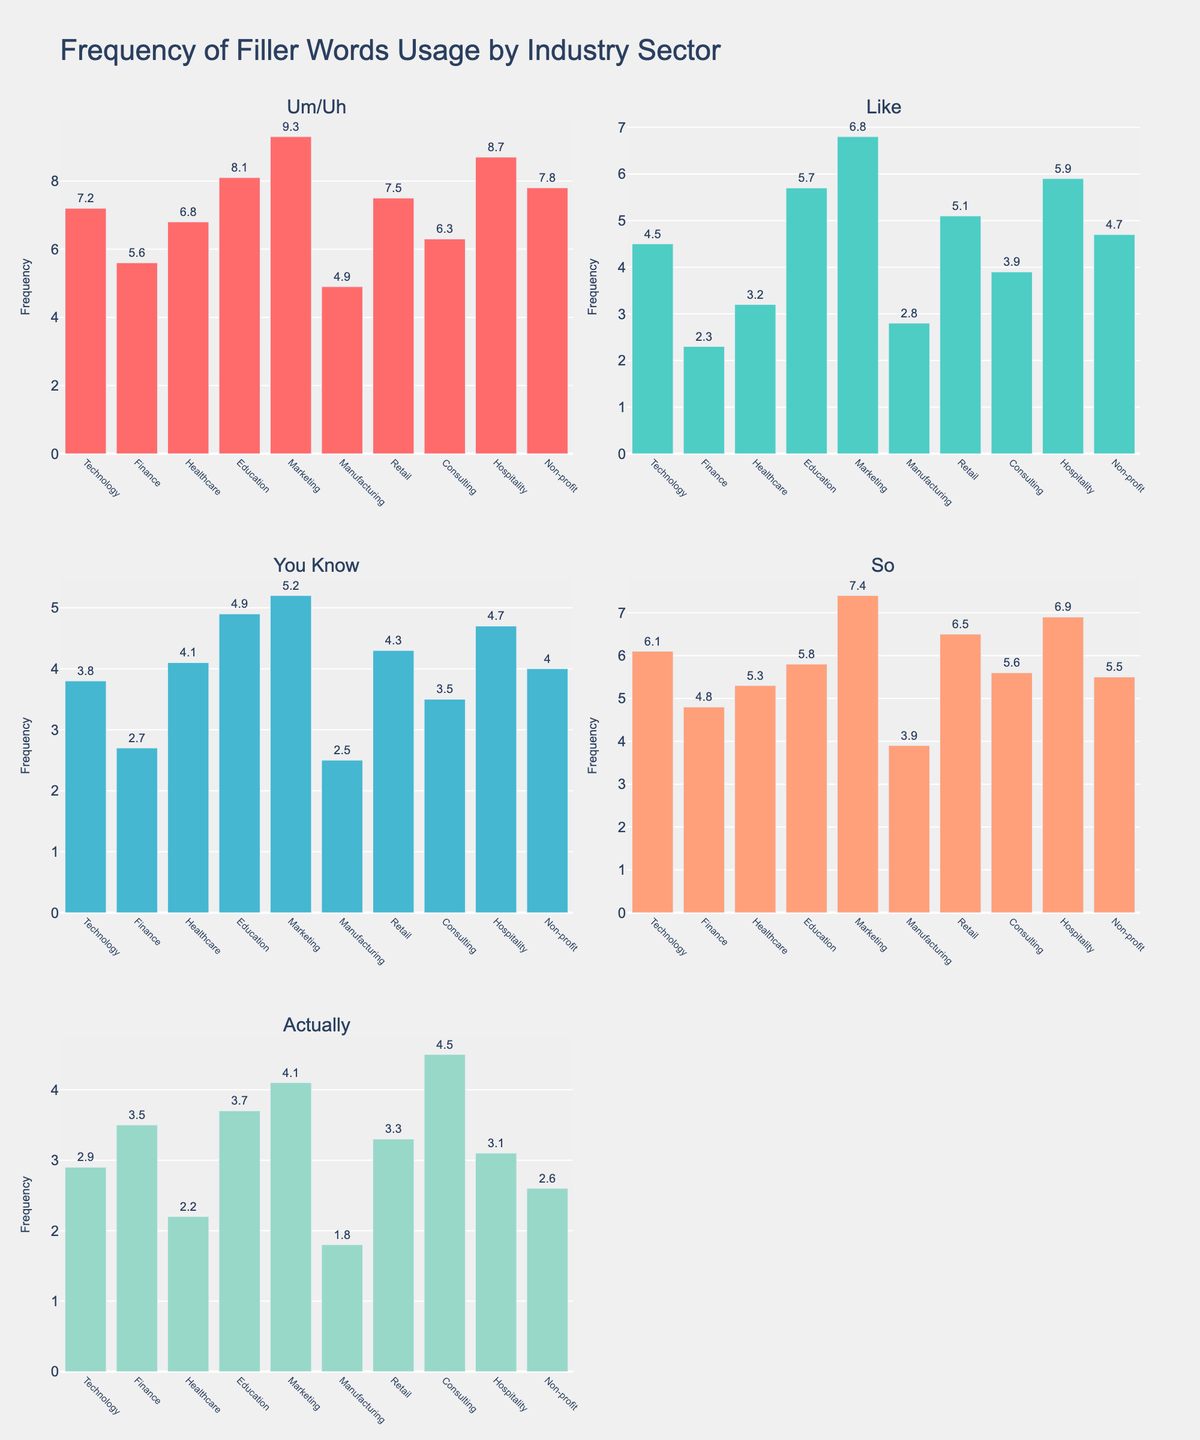What's the title of the figure? The title of the figure is located at the top of the plot. It helps readers understand the content at a glance.
Answer: Frequency of Filler Words Usage by Industry Sector How many subplots are there in the figure? There are several smaller plots within the larger figure. By counting each individual subplot, we can determine the total.
Answer: 5 Which industry uses the word "Like" the most? By looking at the subplot titled "Like" and comparing the heights of the bars, you can identify the industry with the highest frequency.
Answer: Marketing Between "Retail" and "Healthcare," which industry uses "So" more frequently? In the subplot corresponding to "So," compare the heights of the bars for "Retail" and "Healthcare." The taller bar indicates higher usage.
Answer: Retail What is the frequency of "Um/Uh" in the Education sector? Locate the subplot named "Um/Uh." Find the bar labeled "Education" and read the frequency value from the top of the bar.
Answer: 8.1 Which filler word is used the least by the Manufacturing industry? Examine the subplot for each filler word. Find the bar labelled "Manufacturing," and compare their heights to identify the smallest value.
Answer: Actually What is the average frequency of "Actually" across all industries? Sum the frequencies of "Actually" for all industries and divide by the total number of industries (10).
Answer: 3.17 Which industry shows the highest frequency for "You Know"? Look at the "You Know" subplot and identify the bar with the greatest height.
Answer: Education How much more frequently does Hospitality use "Like" compared to Finance? Locate the "Like" subplot, find the bars for Hospitality and Finance, and subtract the frequency of Finance from Hospitality.
Answer: 3.6 Compare the usage of "So" between Technology and Consulting. Which one is higher and by how much? In the "So" subplot, identify the bars for Technology and Consulting. Subtract the frequency of Consulting from that of Technology to find the difference.
Answer: Technology by 0.5 